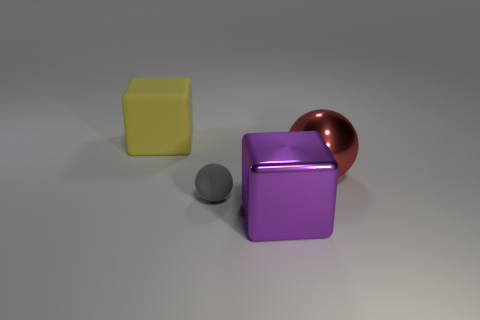Can you tell me the colors of the objects in the image? Certainly! There are three objects with distinct colors: a yellow cube, a grey small sphere, and a big purple cube with a metallic, copper-colored sphere on top. 